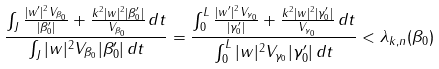Convert formula to latex. <formula><loc_0><loc_0><loc_500><loc_500>\frac { \int _ { J } \frac { | w ^ { \prime } | ^ { 2 } V _ { \beta _ { 0 } } } { | \beta _ { 0 } ^ { \prime } | } + \frac { k ^ { 2 } | w | ^ { 2 } | \beta _ { 0 } ^ { \prime } | } { V _ { \beta _ { 0 } } } \, d t } { \int _ { J } | w | ^ { 2 } V _ { \beta _ { 0 } } | \beta _ { 0 } ^ { \prime } | \, d t } = \frac { \int _ { 0 } ^ { L } \frac { | w ^ { \prime } | ^ { 2 } V _ { \gamma _ { 0 } } } { | \gamma _ { 0 } ^ { \prime } | } + \frac { k ^ { 2 } | w | ^ { 2 } | \gamma _ { 0 } ^ { \prime } | } { V _ { \gamma _ { 0 } } } \, d t } { \int _ { 0 } ^ { L } | w | ^ { 2 } V _ { \gamma _ { 0 } } | \gamma _ { 0 } ^ { \prime } | \, d t } < \lambda _ { k , n } ( \beta _ { 0 } )</formula> 